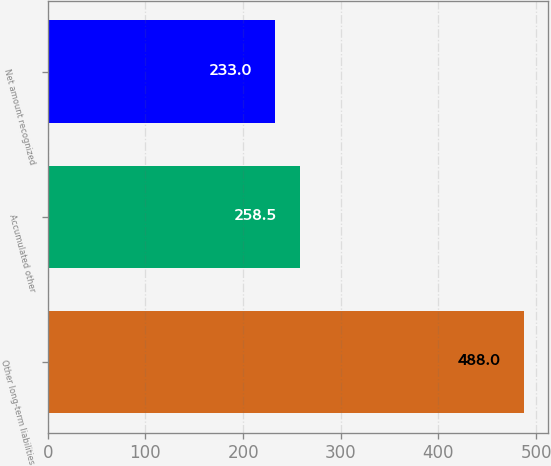Convert chart. <chart><loc_0><loc_0><loc_500><loc_500><bar_chart><fcel>Other long-term liabilities<fcel>Accumulated other<fcel>Net amount recognized<nl><fcel>488<fcel>258.5<fcel>233<nl></chart> 